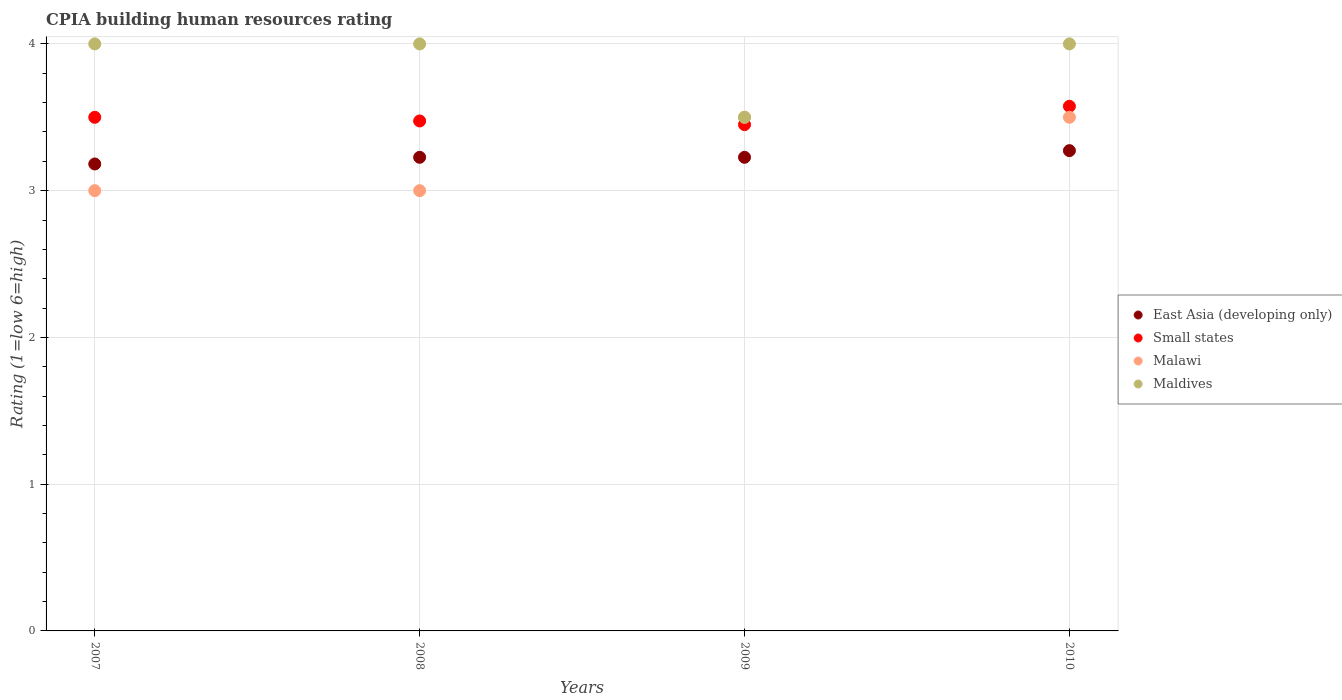Is the number of dotlines equal to the number of legend labels?
Provide a short and direct response. Yes. What is the CPIA rating in Small states in 2007?
Offer a very short reply. 3.5. Across all years, what is the maximum CPIA rating in Malawi?
Your response must be concise. 3.5. In which year was the CPIA rating in Small states minimum?
Provide a succinct answer. 2009. What is the total CPIA rating in Small states in the graph?
Offer a very short reply. 14. What is the difference between the CPIA rating in Malawi in 2008 and that in 2010?
Ensure brevity in your answer.  -0.5. What is the difference between the CPIA rating in East Asia (developing only) in 2010 and the CPIA rating in Maldives in 2008?
Your response must be concise. -0.73. In the year 2009, what is the difference between the CPIA rating in East Asia (developing only) and CPIA rating in Maldives?
Offer a very short reply. -0.27. In how many years, is the CPIA rating in East Asia (developing only) greater than 3.2?
Give a very brief answer. 3. What is the ratio of the CPIA rating in East Asia (developing only) in 2008 to that in 2010?
Provide a succinct answer. 0.99. Is the difference between the CPIA rating in East Asia (developing only) in 2007 and 2008 greater than the difference between the CPIA rating in Maldives in 2007 and 2008?
Make the answer very short. No. What is the difference between the highest and the second highest CPIA rating in East Asia (developing only)?
Your response must be concise. 0.05. Is it the case that in every year, the sum of the CPIA rating in East Asia (developing only) and CPIA rating in Small states  is greater than the sum of CPIA rating in Malawi and CPIA rating in Maldives?
Your answer should be compact. No. Is the CPIA rating in Malawi strictly greater than the CPIA rating in East Asia (developing only) over the years?
Your answer should be compact. No. Is the CPIA rating in Maldives strictly less than the CPIA rating in East Asia (developing only) over the years?
Keep it short and to the point. No. How many legend labels are there?
Your answer should be very brief. 4. How are the legend labels stacked?
Your answer should be compact. Vertical. What is the title of the graph?
Your answer should be very brief. CPIA building human resources rating. What is the label or title of the X-axis?
Ensure brevity in your answer.  Years. What is the label or title of the Y-axis?
Give a very brief answer. Rating (1=low 6=high). What is the Rating (1=low 6=high) of East Asia (developing only) in 2007?
Offer a very short reply. 3.18. What is the Rating (1=low 6=high) of Maldives in 2007?
Provide a succinct answer. 4. What is the Rating (1=low 6=high) of East Asia (developing only) in 2008?
Provide a short and direct response. 3.23. What is the Rating (1=low 6=high) of Small states in 2008?
Provide a short and direct response. 3.48. What is the Rating (1=low 6=high) of Malawi in 2008?
Your response must be concise. 3. What is the Rating (1=low 6=high) in Maldives in 2008?
Keep it short and to the point. 4. What is the Rating (1=low 6=high) in East Asia (developing only) in 2009?
Keep it short and to the point. 3.23. What is the Rating (1=low 6=high) in Small states in 2009?
Your answer should be very brief. 3.45. What is the Rating (1=low 6=high) of East Asia (developing only) in 2010?
Offer a terse response. 3.27. What is the Rating (1=low 6=high) of Small states in 2010?
Keep it short and to the point. 3.58. What is the Rating (1=low 6=high) of Maldives in 2010?
Make the answer very short. 4. Across all years, what is the maximum Rating (1=low 6=high) in East Asia (developing only)?
Make the answer very short. 3.27. Across all years, what is the maximum Rating (1=low 6=high) in Small states?
Keep it short and to the point. 3.58. Across all years, what is the minimum Rating (1=low 6=high) in East Asia (developing only)?
Your answer should be compact. 3.18. Across all years, what is the minimum Rating (1=low 6=high) of Small states?
Your answer should be compact. 3.45. Across all years, what is the minimum Rating (1=low 6=high) of Malawi?
Offer a terse response. 3. What is the total Rating (1=low 6=high) in East Asia (developing only) in the graph?
Provide a succinct answer. 12.91. What is the total Rating (1=low 6=high) of Small states in the graph?
Offer a very short reply. 14. What is the total Rating (1=low 6=high) in Malawi in the graph?
Give a very brief answer. 13. What is the total Rating (1=low 6=high) in Maldives in the graph?
Offer a very short reply. 15.5. What is the difference between the Rating (1=low 6=high) in East Asia (developing only) in 2007 and that in 2008?
Your answer should be compact. -0.05. What is the difference between the Rating (1=low 6=high) of Small states in 2007 and that in 2008?
Offer a very short reply. 0.03. What is the difference between the Rating (1=low 6=high) in Malawi in 2007 and that in 2008?
Keep it short and to the point. 0. What is the difference between the Rating (1=low 6=high) in East Asia (developing only) in 2007 and that in 2009?
Offer a terse response. -0.05. What is the difference between the Rating (1=low 6=high) of Small states in 2007 and that in 2009?
Make the answer very short. 0.05. What is the difference between the Rating (1=low 6=high) in East Asia (developing only) in 2007 and that in 2010?
Offer a terse response. -0.09. What is the difference between the Rating (1=low 6=high) in Small states in 2007 and that in 2010?
Keep it short and to the point. -0.07. What is the difference between the Rating (1=low 6=high) of Malawi in 2007 and that in 2010?
Your response must be concise. -0.5. What is the difference between the Rating (1=low 6=high) in Maldives in 2007 and that in 2010?
Your answer should be compact. 0. What is the difference between the Rating (1=low 6=high) of East Asia (developing only) in 2008 and that in 2009?
Your answer should be compact. 0. What is the difference between the Rating (1=low 6=high) in Small states in 2008 and that in 2009?
Your answer should be very brief. 0.03. What is the difference between the Rating (1=low 6=high) in Malawi in 2008 and that in 2009?
Offer a terse response. -0.5. What is the difference between the Rating (1=low 6=high) in Maldives in 2008 and that in 2009?
Keep it short and to the point. 0.5. What is the difference between the Rating (1=low 6=high) in East Asia (developing only) in 2008 and that in 2010?
Ensure brevity in your answer.  -0.05. What is the difference between the Rating (1=low 6=high) of Malawi in 2008 and that in 2010?
Keep it short and to the point. -0.5. What is the difference between the Rating (1=low 6=high) of Maldives in 2008 and that in 2010?
Offer a very short reply. 0. What is the difference between the Rating (1=low 6=high) of East Asia (developing only) in 2009 and that in 2010?
Give a very brief answer. -0.05. What is the difference between the Rating (1=low 6=high) of Small states in 2009 and that in 2010?
Your response must be concise. -0.12. What is the difference between the Rating (1=low 6=high) in Maldives in 2009 and that in 2010?
Your response must be concise. -0.5. What is the difference between the Rating (1=low 6=high) in East Asia (developing only) in 2007 and the Rating (1=low 6=high) in Small states in 2008?
Keep it short and to the point. -0.29. What is the difference between the Rating (1=low 6=high) in East Asia (developing only) in 2007 and the Rating (1=low 6=high) in Malawi in 2008?
Provide a succinct answer. 0.18. What is the difference between the Rating (1=low 6=high) in East Asia (developing only) in 2007 and the Rating (1=low 6=high) in Maldives in 2008?
Provide a short and direct response. -0.82. What is the difference between the Rating (1=low 6=high) of Small states in 2007 and the Rating (1=low 6=high) of Malawi in 2008?
Offer a very short reply. 0.5. What is the difference between the Rating (1=low 6=high) in Small states in 2007 and the Rating (1=low 6=high) in Maldives in 2008?
Give a very brief answer. -0.5. What is the difference between the Rating (1=low 6=high) in Malawi in 2007 and the Rating (1=low 6=high) in Maldives in 2008?
Ensure brevity in your answer.  -1. What is the difference between the Rating (1=low 6=high) of East Asia (developing only) in 2007 and the Rating (1=low 6=high) of Small states in 2009?
Your answer should be very brief. -0.27. What is the difference between the Rating (1=low 6=high) in East Asia (developing only) in 2007 and the Rating (1=low 6=high) in Malawi in 2009?
Ensure brevity in your answer.  -0.32. What is the difference between the Rating (1=low 6=high) of East Asia (developing only) in 2007 and the Rating (1=low 6=high) of Maldives in 2009?
Offer a terse response. -0.32. What is the difference between the Rating (1=low 6=high) in Small states in 2007 and the Rating (1=low 6=high) in Malawi in 2009?
Offer a very short reply. 0. What is the difference between the Rating (1=low 6=high) of Small states in 2007 and the Rating (1=low 6=high) of Maldives in 2009?
Ensure brevity in your answer.  0. What is the difference between the Rating (1=low 6=high) of East Asia (developing only) in 2007 and the Rating (1=low 6=high) of Small states in 2010?
Give a very brief answer. -0.39. What is the difference between the Rating (1=low 6=high) in East Asia (developing only) in 2007 and the Rating (1=low 6=high) in Malawi in 2010?
Your answer should be compact. -0.32. What is the difference between the Rating (1=low 6=high) in East Asia (developing only) in 2007 and the Rating (1=low 6=high) in Maldives in 2010?
Your response must be concise. -0.82. What is the difference between the Rating (1=low 6=high) in Small states in 2007 and the Rating (1=low 6=high) in Malawi in 2010?
Provide a succinct answer. 0. What is the difference between the Rating (1=low 6=high) of Small states in 2007 and the Rating (1=low 6=high) of Maldives in 2010?
Ensure brevity in your answer.  -0.5. What is the difference between the Rating (1=low 6=high) of East Asia (developing only) in 2008 and the Rating (1=low 6=high) of Small states in 2009?
Provide a short and direct response. -0.22. What is the difference between the Rating (1=low 6=high) in East Asia (developing only) in 2008 and the Rating (1=low 6=high) in Malawi in 2009?
Offer a terse response. -0.27. What is the difference between the Rating (1=low 6=high) in East Asia (developing only) in 2008 and the Rating (1=low 6=high) in Maldives in 2009?
Provide a succinct answer. -0.27. What is the difference between the Rating (1=low 6=high) in Small states in 2008 and the Rating (1=low 6=high) in Malawi in 2009?
Make the answer very short. -0.03. What is the difference between the Rating (1=low 6=high) of Small states in 2008 and the Rating (1=low 6=high) of Maldives in 2009?
Make the answer very short. -0.03. What is the difference between the Rating (1=low 6=high) in East Asia (developing only) in 2008 and the Rating (1=low 6=high) in Small states in 2010?
Make the answer very short. -0.35. What is the difference between the Rating (1=low 6=high) in East Asia (developing only) in 2008 and the Rating (1=low 6=high) in Malawi in 2010?
Give a very brief answer. -0.27. What is the difference between the Rating (1=low 6=high) in East Asia (developing only) in 2008 and the Rating (1=low 6=high) in Maldives in 2010?
Keep it short and to the point. -0.77. What is the difference between the Rating (1=low 6=high) of Small states in 2008 and the Rating (1=low 6=high) of Malawi in 2010?
Offer a terse response. -0.03. What is the difference between the Rating (1=low 6=high) of Small states in 2008 and the Rating (1=low 6=high) of Maldives in 2010?
Provide a succinct answer. -0.53. What is the difference between the Rating (1=low 6=high) of East Asia (developing only) in 2009 and the Rating (1=low 6=high) of Small states in 2010?
Provide a short and direct response. -0.35. What is the difference between the Rating (1=low 6=high) of East Asia (developing only) in 2009 and the Rating (1=low 6=high) of Malawi in 2010?
Your answer should be very brief. -0.27. What is the difference between the Rating (1=low 6=high) in East Asia (developing only) in 2009 and the Rating (1=low 6=high) in Maldives in 2010?
Provide a short and direct response. -0.77. What is the difference between the Rating (1=low 6=high) in Small states in 2009 and the Rating (1=low 6=high) in Maldives in 2010?
Offer a very short reply. -0.55. What is the average Rating (1=low 6=high) in East Asia (developing only) per year?
Offer a very short reply. 3.23. What is the average Rating (1=low 6=high) in Malawi per year?
Ensure brevity in your answer.  3.25. What is the average Rating (1=low 6=high) of Maldives per year?
Your answer should be very brief. 3.88. In the year 2007, what is the difference between the Rating (1=low 6=high) in East Asia (developing only) and Rating (1=low 6=high) in Small states?
Your response must be concise. -0.32. In the year 2007, what is the difference between the Rating (1=low 6=high) in East Asia (developing only) and Rating (1=low 6=high) in Malawi?
Give a very brief answer. 0.18. In the year 2007, what is the difference between the Rating (1=low 6=high) in East Asia (developing only) and Rating (1=low 6=high) in Maldives?
Give a very brief answer. -0.82. In the year 2007, what is the difference between the Rating (1=low 6=high) of Small states and Rating (1=low 6=high) of Maldives?
Offer a very short reply. -0.5. In the year 2007, what is the difference between the Rating (1=low 6=high) of Malawi and Rating (1=low 6=high) of Maldives?
Your response must be concise. -1. In the year 2008, what is the difference between the Rating (1=low 6=high) in East Asia (developing only) and Rating (1=low 6=high) in Small states?
Provide a succinct answer. -0.25. In the year 2008, what is the difference between the Rating (1=low 6=high) in East Asia (developing only) and Rating (1=low 6=high) in Malawi?
Provide a succinct answer. 0.23. In the year 2008, what is the difference between the Rating (1=low 6=high) in East Asia (developing only) and Rating (1=low 6=high) in Maldives?
Offer a very short reply. -0.77. In the year 2008, what is the difference between the Rating (1=low 6=high) of Small states and Rating (1=low 6=high) of Malawi?
Give a very brief answer. 0.47. In the year 2008, what is the difference between the Rating (1=low 6=high) in Small states and Rating (1=low 6=high) in Maldives?
Make the answer very short. -0.53. In the year 2009, what is the difference between the Rating (1=low 6=high) in East Asia (developing only) and Rating (1=low 6=high) in Small states?
Your answer should be compact. -0.22. In the year 2009, what is the difference between the Rating (1=low 6=high) of East Asia (developing only) and Rating (1=low 6=high) of Malawi?
Ensure brevity in your answer.  -0.27. In the year 2009, what is the difference between the Rating (1=low 6=high) in East Asia (developing only) and Rating (1=low 6=high) in Maldives?
Offer a very short reply. -0.27. In the year 2010, what is the difference between the Rating (1=low 6=high) in East Asia (developing only) and Rating (1=low 6=high) in Small states?
Your response must be concise. -0.3. In the year 2010, what is the difference between the Rating (1=low 6=high) in East Asia (developing only) and Rating (1=low 6=high) in Malawi?
Provide a succinct answer. -0.23. In the year 2010, what is the difference between the Rating (1=low 6=high) in East Asia (developing only) and Rating (1=low 6=high) in Maldives?
Your answer should be very brief. -0.73. In the year 2010, what is the difference between the Rating (1=low 6=high) in Small states and Rating (1=low 6=high) in Malawi?
Offer a very short reply. 0.07. In the year 2010, what is the difference between the Rating (1=low 6=high) of Small states and Rating (1=low 6=high) of Maldives?
Offer a terse response. -0.42. What is the ratio of the Rating (1=low 6=high) in East Asia (developing only) in 2007 to that in 2008?
Your response must be concise. 0.99. What is the ratio of the Rating (1=low 6=high) of Malawi in 2007 to that in 2008?
Your response must be concise. 1. What is the ratio of the Rating (1=low 6=high) in Maldives in 2007 to that in 2008?
Make the answer very short. 1. What is the ratio of the Rating (1=low 6=high) in East Asia (developing only) in 2007 to that in 2009?
Offer a very short reply. 0.99. What is the ratio of the Rating (1=low 6=high) in Small states in 2007 to that in 2009?
Your answer should be very brief. 1.01. What is the ratio of the Rating (1=low 6=high) in East Asia (developing only) in 2007 to that in 2010?
Ensure brevity in your answer.  0.97. What is the ratio of the Rating (1=low 6=high) of Small states in 2007 to that in 2010?
Your answer should be compact. 0.98. What is the ratio of the Rating (1=low 6=high) in Maldives in 2007 to that in 2010?
Your response must be concise. 1. What is the ratio of the Rating (1=low 6=high) in Maldives in 2008 to that in 2009?
Give a very brief answer. 1.14. What is the ratio of the Rating (1=low 6=high) in East Asia (developing only) in 2008 to that in 2010?
Your response must be concise. 0.99. What is the ratio of the Rating (1=low 6=high) in Malawi in 2008 to that in 2010?
Provide a succinct answer. 0.86. What is the ratio of the Rating (1=low 6=high) in East Asia (developing only) in 2009 to that in 2010?
Give a very brief answer. 0.99. What is the difference between the highest and the second highest Rating (1=low 6=high) of East Asia (developing only)?
Provide a succinct answer. 0.05. What is the difference between the highest and the second highest Rating (1=low 6=high) of Small states?
Make the answer very short. 0.07. What is the difference between the highest and the second highest Rating (1=low 6=high) in Malawi?
Ensure brevity in your answer.  0. What is the difference between the highest and the lowest Rating (1=low 6=high) in East Asia (developing only)?
Your answer should be very brief. 0.09. What is the difference between the highest and the lowest Rating (1=low 6=high) of Maldives?
Offer a very short reply. 0.5. 